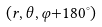<formula> <loc_0><loc_0><loc_500><loc_500>( r , \theta , \varphi { + } 1 8 0 ^ { \circ } )</formula> 